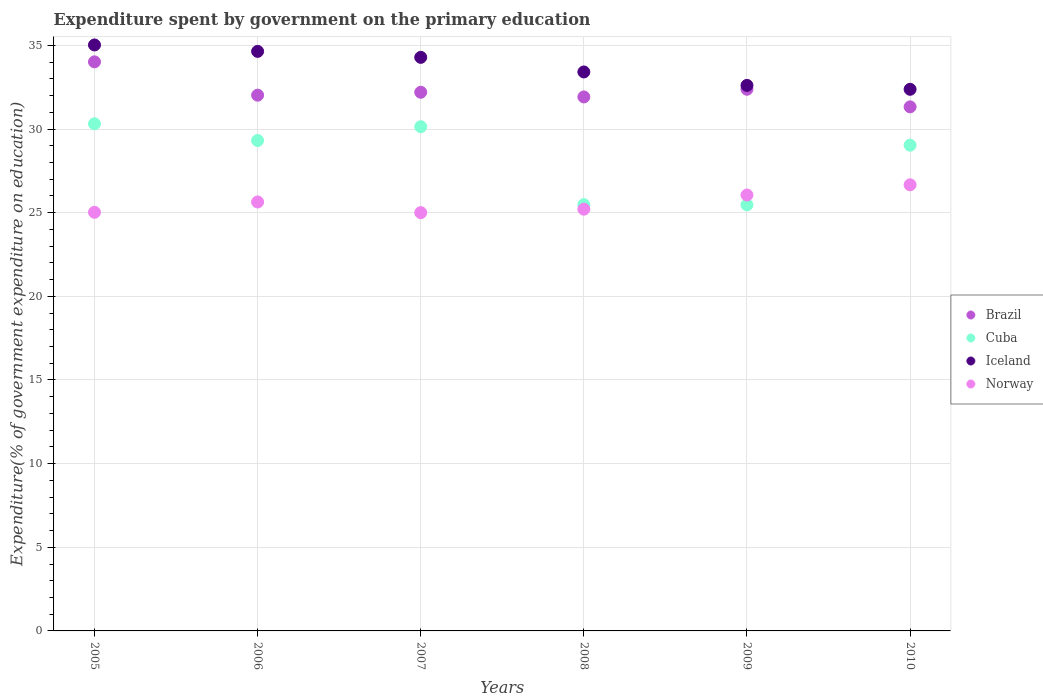What is the expenditure spent by government on the primary education in Norway in 2009?
Make the answer very short. 26.06. Across all years, what is the maximum expenditure spent by government on the primary education in Cuba?
Give a very brief answer. 30.31. Across all years, what is the minimum expenditure spent by government on the primary education in Brazil?
Make the answer very short. 31.33. In which year was the expenditure spent by government on the primary education in Brazil maximum?
Provide a succinct answer. 2005. In which year was the expenditure spent by government on the primary education in Norway minimum?
Provide a short and direct response. 2007. What is the total expenditure spent by government on the primary education in Norway in the graph?
Make the answer very short. 153.6. What is the difference between the expenditure spent by government on the primary education in Iceland in 2006 and that in 2008?
Offer a terse response. 1.23. What is the difference between the expenditure spent by government on the primary education in Brazil in 2005 and the expenditure spent by government on the primary education in Norway in 2010?
Your answer should be very brief. 7.35. What is the average expenditure spent by government on the primary education in Norway per year?
Your response must be concise. 25.6. In the year 2007, what is the difference between the expenditure spent by government on the primary education in Iceland and expenditure spent by government on the primary education in Norway?
Offer a terse response. 9.28. In how many years, is the expenditure spent by government on the primary education in Brazil greater than 32 %?
Provide a short and direct response. 4. What is the ratio of the expenditure spent by government on the primary education in Norway in 2005 to that in 2010?
Provide a succinct answer. 0.94. What is the difference between the highest and the second highest expenditure spent by government on the primary education in Norway?
Your answer should be compact. 0.61. What is the difference between the highest and the lowest expenditure spent by government on the primary education in Iceland?
Ensure brevity in your answer.  2.65. Is the sum of the expenditure spent by government on the primary education in Iceland in 2008 and 2009 greater than the maximum expenditure spent by government on the primary education in Cuba across all years?
Give a very brief answer. Yes. Is it the case that in every year, the sum of the expenditure spent by government on the primary education in Norway and expenditure spent by government on the primary education in Brazil  is greater than the sum of expenditure spent by government on the primary education in Iceland and expenditure spent by government on the primary education in Cuba?
Your answer should be very brief. Yes. Is it the case that in every year, the sum of the expenditure spent by government on the primary education in Cuba and expenditure spent by government on the primary education in Iceland  is greater than the expenditure spent by government on the primary education in Brazil?
Offer a terse response. Yes. What is the difference between two consecutive major ticks on the Y-axis?
Make the answer very short. 5. Are the values on the major ticks of Y-axis written in scientific E-notation?
Ensure brevity in your answer.  No. Does the graph contain any zero values?
Ensure brevity in your answer.  No. Does the graph contain grids?
Make the answer very short. Yes. Where does the legend appear in the graph?
Provide a succinct answer. Center right. How many legend labels are there?
Make the answer very short. 4. How are the legend labels stacked?
Give a very brief answer. Vertical. What is the title of the graph?
Ensure brevity in your answer.  Expenditure spent by government on the primary education. What is the label or title of the Y-axis?
Make the answer very short. Expenditure(% of government expenditure on education). What is the Expenditure(% of government expenditure on education) in Brazil in 2005?
Keep it short and to the point. 34.02. What is the Expenditure(% of government expenditure on education) in Cuba in 2005?
Give a very brief answer. 30.31. What is the Expenditure(% of government expenditure on education) of Iceland in 2005?
Provide a short and direct response. 35.03. What is the Expenditure(% of government expenditure on education) in Norway in 2005?
Your answer should be compact. 25.02. What is the Expenditure(% of government expenditure on education) of Brazil in 2006?
Provide a short and direct response. 32.02. What is the Expenditure(% of government expenditure on education) in Cuba in 2006?
Offer a terse response. 29.31. What is the Expenditure(% of government expenditure on education) in Iceland in 2006?
Provide a succinct answer. 34.64. What is the Expenditure(% of government expenditure on education) in Norway in 2006?
Offer a terse response. 25.64. What is the Expenditure(% of government expenditure on education) in Brazil in 2007?
Provide a short and direct response. 32.2. What is the Expenditure(% of government expenditure on education) of Cuba in 2007?
Offer a very short reply. 30.14. What is the Expenditure(% of government expenditure on education) in Iceland in 2007?
Give a very brief answer. 34.29. What is the Expenditure(% of government expenditure on education) in Norway in 2007?
Ensure brevity in your answer.  25. What is the Expenditure(% of government expenditure on education) in Brazil in 2008?
Your response must be concise. 31.92. What is the Expenditure(% of government expenditure on education) in Cuba in 2008?
Make the answer very short. 25.48. What is the Expenditure(% of government expenditure on education) in Iceland in 2008?
Keep it short and to the point. 33.41. What is the Expenditure(% of government expenditure on education) of Norway in 2008?
Your answer should be very brief. 25.21. What is the Expenditure(% of government expenditure on education) of Brazil in 2009?
Ensure brevity in your answer.  32.38. What is the Expenditure(% of government expenditure on education) in Cuba in 2009?
Provide a succinct answer. 25.47. What is the Expenditure(% of government expenditure on education) of Iceland in 2009?
Ensure brevity in your answer.  32.61. What is the Expenditure(% of government expenditure on education) in Norway in 2009?
Give a very brief answer. 26.06. What is the Expenditure(% of government expenditure on education) in Brazil in 2010?
Provide a succinct answer. 31.33. What is the Expenditure(% of government expenditure on education) of Cuba in 2010?
Ensure brevity in your answer.  29.04. What is the Expenditure(% of government expenditure on education) in Iceland in 2010?
Offer a terse response. 32.38. What is the Expenditure(% of government expenditure on education) in Norway in 2010?
Offer a terse response. 26.67. Across all years, what is the maximum Expenditure(% of government expenditure on education) of Brazil?
Provide a succinct answer. 34.02. Across all years, what is the maximum Expenditure(% of government expenditure on education) in Cuba?
Make the answer very short. 30.31. Across all years, what is the maximum Expenditure(% of government expenditure on education) in Iceland?
Offer a very short reply. 35.03. Across all years, what is the maximum Expenditure(% of government expenditure on education) in Norway?
Make the answer very short. 26.67. Across all years, what is the minimum Expenditure(% of government expenditure on education) in Brazil?
Ensure brevity in your answer.  31.33. Across all years, what is the minimum Expenditure(% of government expenditure on education) in Cuba?
Your answer should be very brief. 25.47. Across all years, what is the minimum Expenditure(% of government expenditure on education) of Iceland?
Offer a very short reply. 32.38. Across all years, what is the minimum Expenditure(% of government expenditure on education) in Norway?
Your response must be concise. 25. What is the total Expenditure(% of government expenditure on education) in Brazil in the graph?
Give a very brief answer. 193.86. What is the total Expenditure(% of government expenditure on education) in Cuba in the graph?
Your response must be concise. 169.75. What is the total Expenditure(% of government expenditure on education) of Iceland in the graph?
Your response must be concise. 202.35. What is the total Expenditure(% of government expenditure on education) of Norway in the graph?
Offer a very short reply. 153.6. What is the difference between the Expenditure(% of government expenditure on education) in Brazil in 2005 and that in 2006?
Your answer should be very brief. 1.99. What is the difference between the Expenditure(% of government expenditure on education) in Cuba in 2005 and that in 2006?
Keep it short and to the point. 1. What is the difference between the Expenditure(% of government expenditure on education) in Iceland in 2005 and that in 2006?
Your answer should be compact. 0.38. What is the difference between the Expenditure(% of government expenditure on education) of Norway in 2005 and that in 2006?
Ensure brevity in your answer.  -0.62. What is the difference between the Expenditure(% of government expenditure on education) in Brazil in 2005 and that in 2007?
Your answer should be very brief. 1.82. What is the difference between the Expenditure(% of government expenditure on education) of Cuba in 2005 and that in 2007?
Offer a very short reply. 0.17. What is the difference between the Expenditure(% of government expenditure on education) in Iceland in 2005 and that in 2007?
Give a very brief answer. 0.74. What is the difference between the Expenditure(% of government expenditure on education) in Norway in 2005 and that in 2007?
Offer a very short reply. 0.02. What is the difference between the Expenditure(% of government expenditure on education) in Brazil in 2005 and that in 2008?
Give a very brief answer. 2.1. What is the difference between the Expenditure(% of government expenditure on education) in Cuba in 2005 and that in 2008?
Your answer should be compact. 4.83. What is the difference between the Expenditure(% of government expenditure on education) in Iceland in 2005 and that in 2008?
Give a very brief answer. 1.61. What is the difference between the Expenditure(% of government expenditure on education) in Norway in 2005 and that in 2008?
Provide a short and direct response. -0.19. What is the difference between the Expenditure(% of government expenditure on education) in Brazil in 2005 and that in 2009?
Your response must be concise. 1.64. What is the difference between the Expenditure(% of government expenditure on education) in Cuba in 2005 and that in 2009?
Keep it short and to the point. 4.85. What is the difference between the Expenditure(% of government expenditure on education) in Iceland in 2005 and that in 2009?
Give a very brief answer. 2.42. What is the difference between the Expenditure(% of government expenditure on education) of Norway in 2005 and that in 2009?
Keep it short and to the point. -1.03. What is the difference between the Expenditure(% of government expenditure on education) of Brazil in 2005 and that in 2010?
Your answer should be compact. 2.69. What is the difference between the Expenditure(% of government expenditure on education) of Cuba in 2005 and that in 2010?
Keep it short and to the point. 1.28. What is the difference between the Expenditure(% of government expenditure on education) in Iceland in 2005 and that in 2010?
Offer a very short reply. 2.65. What is the difference between the Expenditure(% of government expenditure on education) in Norway in 2005 and that in 2010?
Your answer should be very brief. -1.64. What is the difference between the Expenditure(% of government expenditure on education) in Brazil in 2006 and that in 2007?
Ensure brevity in your answer.  -0.17. What is the difference between the Expenditure(% of government expenditure on education) in Cuba in 2006 and that in 2007?
Your response must be concise. -0.82. What is the difference between the Expenditure(% of government expenditure on education) in Iceland in 2006 and that in 2007?
Ensure brevity in your answer.  0.36. What is the difference between the Expenditure(% of government expenditure on education) in Norway in 2006 and that in 2007?
Your answer should be compact. 0.64. What is the difference between the Expenditure(% of government expenditure on education) in Brazil in 2006 and that in 2008?
Provide a short and direct response. 0.11. What is the difference between the Expenditure(% of government expenditure on education) in Cuba in 2006 and that in 2008?
Your answer should be compact. 3.84. What is the difference between the Expenditure(% of government expenditure on education) in Iceland in 2006 and that in 2008?
Provide a succinct answer. 1.23. What is the difference between the Expenditure(% of government expenditure on education) of Norway in 2006 and that in 2008?
Your answer should be very brief. 0.43. What is the difference between the Expenditure(% of government expenditure on education) of Brazil in 2006 and that in 2009?
Give a very brief answer. -0.35. What is the difference between the Expenditure(% of government expenditure on education) in Cuba in 2006 and that in 2009?
Keep it short and to the point. 3.85. What is the difference between the Expenditure(% of government expenditure on education) of Iceland in 2006 and that in 2009?
Provide a short and direct response. 2.03. What is the difference between the Expenditure(% of government expenditure on education) of Norway in 2006 and that in 2009?
Your answer should be compact. -0.42. What is the difference between the Expenditure(% of government expenditure on education) of Brazil in 2006 and that in 2010?
Provide a short and direct response. 0.7. What is the difference between the Expenditure(% of government expenditure on education) of Cuba in 2006 and that in 2010?
Your answer should be compact. 0.28. What is the difference between the Expenditure(% of government expenditure on education) of Iceland in 2006 and that in 2010?
Offer a terse response. 2.27. What is the difference between the Expenditure(% of government expenditure on education) in Norway in 2006 and that in 2010?
Provide a succinct answer. -1.03. What is the difference between the Expenditure(% of government expenditure on education) in Brazil in 2007 and that in 2008?
Offer a very short reply. 0.28. What is the difference between the Expenditure(% of government expenditure on education) in Cuba in 2007 and that in 2008?
Your response must be concise. 4.66. What is the difference between the Expenditure(% of government expenditure on education) in Iceland in 2007 and that in 2008?
Provide a succinct answer. 0.87. What is the difference between the Expenditure(% of government expenditure on education) in Norway in 2007 and that in 2008?
Make the answer very short. -0.21. What is the difference between the Expenditure(% of government expenditure on education) of Brazil in 2007 and that in 2009?
Your answer should be very brief. -0.18. What is the difference between the Expenditure(% of government expenditure on education) of Cuba in 2007 and that in 2009?
Offer a very short reply. 4.67. What is the difference between the Expenditure(% of government expenditure on education) of Iceland in 2007 and that in 2009?
Offer a terse response. 1.68. What is the difference between the Expenditure(% of government expenditure on education) of Norway in 2007 and that in 2009?
Your answer should be compact. -1.05. What is the difference between the Expenditure(% of government expenditure on education) in Brazil in 2007 and that in 2010?
Provide a succinct answer. 0.87. What is the difference between the Expenditure(% of government expenditure on education) of Cuba in 2007 and that in 2010?
Give a very brief answer. 1.1. What is the difference between the Expenditure(% of government expenditure on education) of Iceland in 2007 and that in 2010?
Make the answer very short. 1.91. What is the difference between the Expenditure(% of government expenditure on education) of Norway in 2007 and that in 2010?
Your answer should be very brief. -1.66. What is the difference between the Expenditure(% of government expenditure on education) in Brazil in 2008 and that in 2009?
Make the answer very short. -0.46. What is the difference between the Expenditure(% of government expenditure on education) in Cuba in 2008 and that in 2009?
Give a very brief answer. 0.01. What is the difference between the Expenditure(% of government expenditure on education) in Iceland in 2008 and that in 2009?
Make the answer very short. 0.8. What is the difference between the Expenditure(% of government expenditure on education) of Norway in 2008 and that in 2009?
Ensure brevity in your answer.  -0.85. What is the difference between the Expenditure(% of government expenditure on education) in Brazil in 2008 and that in 2010?
Offer a very short reply. 0.59. What is the difference between the Expenditure(% of government expenditure on education) in Cuba in 2008 and that in 2010?
Offer a very short reply. -3.56. What is the difference between the Expenditure(% of government expenditure on education) in Iceland in 2008 and that in 2010?
Make the answer very short. 1.04. What is the difference between the Expenditure(% of government expenditure on education) of Norway in 2008 and that in 2010?
Give a very brief answer. -1.46. What is the difference between the Expenditure(% of government expenditure on education) in Brazil in 2009 and that in 2010?
Provide a succinct answer. 1.05. What is the difference between the Expenditure(% of government expenditure on education) in Cuba in 2009 and that in 2010?
Ensure brevity in your answer.  -3.57. What is the difference between the Expenditure(% of government expenditure on education) of Iceland in 2009 and that in 2010?
Your response must be concise. 0.23. What is the difference between the Expenditure(% of government expenditure on education) in Norway in 2009 and that in 2010?
Your answer should be compact. -0.61. What is the difference between the Expenditure(% of government expenditure on education) in Brazil in 2005 and the Expenditure(% of government expenditure on education) in Cuba in 2006?
Make the answer very short. 4.7. What is the difference between the Expenditure(% of government expenditure on education) in Brazil in 2005 and the Expenditure(% of government expenditure on education) in Iceland in 2006?
Your response must be concise. -0.63. What is the difference between the Expenditure(% of government expenditure on education) in Brazil in 2005 and the Expenditure(% of government expenditure on education) in Norway in 2006?
Make the answer very short. 8.38. What is the difference between the Expenditure(% of government expenditure on education) of Cuba in 2005 and the Expenditure(% of government expenditure on education) of Iceland in 2006?
Offer a very short reply. -4.33. What is the difference between the Expenditure(% of government expenditure on education) in Cuba in 2005 and the Expenditure(% of government expenditure on education) in Norway in 2006?
Ensure brevity in your answer.  4.67. What is the difference between the Expenditure(% of government expenditure on education) of Iceland in 2005 and the Expenditure(% of government expenditure on education) of Norway in 2006?
Provide a short and direct response. 9.39. What is the difference between the Expenditure(% of government expenditure on education) in Brazil in 2005 and the Expenditure(% of government expenditure on education) in Cuba in 2007?
Provide a short and direct response. 3.88. What is the difference between the Expenditure(% of government expenditure on education) in Brazil in 2005 and the Expenditure(% of government expenditure on education) in Iceland in 2007?
Provide a succinct answer. -0.27. What is the difference between the Expenditure(% of government expenditure on education) in Brazil in 2005 and the Expenditure(% of government expenditure on education) in Norway in 2007?
Keep it short and to the point. 9.01. What is the difference between the Expenditure(% of government expenditure on education) of Cuba in 2005 and the Expenditure(% of government expenditure on education) of Iceland in 2007?
Offer a terse response. -3.97. What is the difference between the Expenditure(% of government expenditure on education) in Cuba in 2005 and the Expenditure(% of government expenditure on education) in Norway in 2007?
Offer a terse response. 5.31. What is the difference between the Expenditure(% of government expenditure on education) in Iceland in 2005 and the Expenditure(% of government expenditure on education) in Norway in 2007?
Provide a short and direct response. 10.02. What is the difference between the Expenditure(% of government expenditure on education) of Brazil in 2005 and the Expenditure(% of government expenditure on education) of Cuba in 2008?
Your answer should be compact. 8.54. What is the difference between the Expenditure(% of government expenditure on education) in Brazil in 2005 and the Expenditure(% of government expenditure on education) in Iceland in 2008?
Your answer should be compact. 0.6. What is the difference between the Expenditure(% of government expenditure on education) of Brazil in 2005 and the Expenditure(% of government expenditure on education) of Norway in 2008?
Offer a terse response. 8.8. What is the difference between the Expenditure(% of government expenditure on education) in Cuba in 2005 and the Expenditure(% of government expenditure on education) in Iceland in 2008?
Provide a succinct answer. -3.1. What is the difference between the Expenditure(% of government expenditure on education) in Cuba in 2005 and the Expenditure(% of government expenditure on education) in Norway in 2008?
Ensure brevity in your answer.  5.1. What is the difference between the Expenditure(% of government expenditure on education) of Iceland in 2005 and the Expenditure(% of government expenditure on education) of Norway in 2008?
Make the answer very short. 9.82. What is the difference between the Expenditure(% of government expenditure on education) in Brazil in 2005 and the Expenditure(% of government expenditure on education) in Cuba in 2009?
Your answer should be compact. 8.55. What is the difference between the Expenditure(% of government expenditure on education) in Brazil in 2005 and the Expenditure(% of government expenditure on education) in Iceland in 2009?
Make the answer very short. 1.41. What is the difference between the Expenditure(% of government expenditure on education) of Brazil in 2005 and the Expenditure(% of government expenditure on education) of Norway in 2009?
Keep it short and to the point. 7.96. What is the difference between the Expenditure(% of government expenditure on education) in Cuba in 2005 and the Expenditure(% of government expenditure on education) in Iceland in 2009?
Offer a terse response. -2.3. What is the difference between the Expenditure(% of government expenditure on education) of Cuba in 2005 and the Expenditure(% of government expenditure on education) of Norway in 2009?
Offer a very short reply. 4.26. What is the difference between the Expenditure(% of government expenditure on education) of Iceland in 2005 and the Expenditure(% of government expenditure on education) of Norway in 2009?
Offer a terse response. 8.97. What is the difference between the Expenditure(% of government expenditure on education) of Brazil in 2005 and the Expenditure(% of government expenditure on education) of Cuba in 2010?
Your answer should be very brief. 4.98. What is the difference between the Expenditure(% of government expenditure on education) of Brazil in 2005 and the Expenditure(% of government expenditure on education) of Iceland in 2010?
Give a very brief answer. 1.64. What is the difference between the Expenditure(% of government expenditure on education) in Brazil in 2005 and the Expenditure(% of government expenditure on education) in Norway in 2010?
Offer a terse response. 7.35. What is the difference between the Expenditure(% of government expenditure on education) of Cuba in 2005 and the Expenditure(% of government expenditure on education) of Iceland in 2010?
Make the answer very short. -2.06. What is the difference between the Expenditure(% of government expenditure on education) of Cuba in 2005 and the Expenditure(% of government expenditure on education) of Norway in 2010?
Your answer should be very brief. 3.65. What is the difference between the Expenditure(% of government expenditure on education) in Iceland in 2005 and the Expenditure(% of government expenditure on education) in Norway in 2010?
Your response must be concise. 8.36. What is the difference between the Expenditure(% of government expenditure on education) in Brazil in 2006 and the Expenditure(% of government expenditure on education) in Cuba in 2007?
Make the answer very short. 1.89. What is the difference between the Expenditure(% of government expenditure on education) of Brazil in 2006 and the Expenditure(% of government expenditure on education) of Iceland in 2007?
Keep it short and to the point. -2.26. What is the difference between the Expenditure(% of government expenditure on education) of Brazil in 2006 and the Expenditure(% of government expenditure on education) of Norway in 2007?
Keep it short and to the point. 7.02. What is the difference between the Expenditure(% of government expenditure on education) in Cuba in 2006 and the Expenditure(% of government expenditure on education) in Iceland in 2007?
Offer a terse response. -4.97. What is the difference between the Expenditure(% of government expenditure on education) of Cuba in 2006 and the Expenditure(% of government expenditure on education) of Norway in 2007?
Your response must be concise. 4.31. What is the difference between the Expenditure(% of government expenditure on education) of Iceland in 2006 and the Expenditure(% of government expenditure on education) of Norway in 2007?
Your answer should be very brief. 9.64. What is the difference between the Expenditure(% of government expenditure on education) of Brazil in 2006 and the Expenditure(% of government expenditure on education) of Cuba in 2008?
Your answer should be compact. 6.55. What is the difference between the Expenditure(% of government expenditure on education) of Brazil in 2006 and the Expenditure(% of government expenditure on education) of Iceland in 2008?
Provide a succinct answer. -1.39. What is the difference between the Expenditure(% of government expenditure on education) in Brazil in 2006 and the Expenditure(% of government expenditure on education) in Norway in 2008?
Provide a succinct answer. 6.81. What is the difference between the Expenditure(% of government expenditure on education) in Cuba in 2006 and the Expenditure(% of government expenditure on education) in Iceland in 2008?
Provide a succinct answer. -4.1. What is the difference between the Expenditure(% of government expenditure on education) in Cuba in 2006 and the Expenditure(% of government expenditure on education) in Norway in 2008?
Offer a very short reply. 4.1. What is the difference between the Expenditure(% of government expenditure on education) of Iceland in 2006 and the Expenditure(% of government expenditure on education) of Norway in 2008?
Provide a short and direct response. 9.43. What is the difference between the Expenditure(% of government expenditure on education) in Brazil in 2006 and the Expenditure(% of government expenditure on education) in Cuba in 2009?
Provide a succinct answer. 6.56. What is the difference between the Expenditure(% of government expenditure on education) of Brazil in 2006 and the Expenditure(% of government expenditure on education) of Iceland in 2009?
Your answer should be compact. -0.58. What is the difference between the Expenditure(% of government expenditure on education) in Brazil in 2006 and the Expenditure(% of government expenditure on education) in Norway in 2009?
Provide a short and direct response. 5.97. What is the difference between the Expenditure(% of government expenditure on education) of Cuba in 2006 and the Expenditure(% of government expenditure on education) of Iceland in 2009?
Your response must be concise. -3.29. What is the difference between the Expenditure(% of government expenditure on education) in Cuba in 2006 and the Expenditure(% of government expenditure on education) in Norway in 2009?
Give a very brief answer. 3.26. What is the difference between the Expenditure(% of government expenditure on education) in Iceland in 2006 and the Expenditure(% of government expenditure on education) in Norway in 2009?
Your answer should be compact. 8.59. What is the difference between the Expenditure(% of government expenditure on education) in Brazil in 2006 and the Expenditure(% of government expenditure on education) in Cuba in 2010?
Your answer should be compact. 2.99. What is the difference between the Expenditure(% of government expenditure on education) of Brazil in 2006 and the Expenditure(% of government expenditure on education) of Iceland in 2010?
Keep it short and to the point. -0.35. What is the difference between the Expenditure(% of government expenditure on education) in Brazil in 2006 and the Expenditure(% of government expenditure on education) in Norway in 2010?
Offer a terse response. 5.36. What is the difference between the Expenditure(% of government expenditure on education) of Cuba in 2006 and the Expenditure(% of government expenditure on education) of Iceland in 2010?
Your answer should be compact. -3.06. What is the difference between the Expenditure(% of government expenditure on education) in Cuba in 2006 and the Expenditure(% of government expenditure on education) in Norway in 2010?
Offer a terse response. 2.65. What is the difference between the Expenditure(% of government expenditure on education) of Iceland in 2006 and the Expenditure(% of government expenditure on education) of Norway in 2010?
Your response must be concise. 7.98. What is the difference between the Expenditure(% of government expenditure on education) in Brazil in 2007 and the Expenditure(% of government expenditure on education) in Cuba in 2008?
Your answer should be compact. 6.72. What is the difference between the Expenditure(% of government expenditure on education) of Brazil in 2007 and the Expenditure(% of government expenditure on education) of Iceland in 2008?
Your response must be concise. -1.21. What is the difference between the Expenditure(% of government expenditure on education) of Brazil in 2007 and the Expenditure(% of government expenditure on education) of Norway in 2008?
Keep it short and to the point. 6.99. What is the difference between the Expenditure(% of government expenditure on education) in Cuba in 2007 and the Expenditure(% of government expenditure on education) in Iceland in 2008?
Offer a terse response. -3.27. What is the difference between the Expenditure(% of government expenditure on education) in Cuba in 2007 and the Expenditure(% of government expenditure on education) in Norway in 2008?
Make the answer very short. 4.93. What is the difference between the Expenditure(% of government expenditure on education) of Iceland in 2007 and the Expenditure(% of government expenditure on education) of Norway in 2008?
Offer a very short reply. 9.07. What is the difference between the Expenditure(% of government expenditure on education) in Brazil in 2007 and the Expenditure(% of government expenditure on education) in Cuba in 2009?
Offer a terse response. 6.73. What is the difference between the Expenditure(% of government expenditure on education) in Brazil in 2007 and the Expenditure(% of government expenditure on education) in Iceland in 2009?
Give a very brief answer. -0.41. What is the difference between the Expenditure(% of government expenditure on education) of Brazil in 2007 and the Expenditure(% of government expenditure on education) of Norway in 2009?
Provide a succinct answer. 6.14. What is the difference between the Expenditure(% of government expenditure on education) in Cuba in 2007 and the Expenditure(% of government expenditure on education) in Iceland in 2009?
Your answer should be very brief. -2.47. What is the difference between the Expenditure(% of government expenditure on education) in Cuba in 2007 and the Expenditure(% of government expenditure on education) in Norway in 2009?
Give a very brief answer. 4.08. What is the difference between the Expenditure(% of government expenditure on education) in Iceland in 2007 and the Expenditure(% of government expenditure on education) in Norway in 2009?
Offer a terse response. 8.23. What is the difference between the Expenditure(% of government expenditure on education) of Brazil in 2007 and the Expenditure(% of government expenditure on education) of Cuba in 2010?
Provide a succinct answer. 3.16. What is the difference between the Expenditure(% of government expenditure on education) in Brazil in 2007 and the Expenditure(% of government expenditure on education) in Iceland in 2010?
Your response must be concise. -0.18. What is the difference between the Expenditure(% of government expenditure on education) in Brazil in 2007 and the Expenditure(% of government expenditure on education) in Norway in 2010?
Provide a short and direct response. 5.53. What is the difference between the Expenditure(% of government expenditure on education) in Cuba in 2007 and the Expenditure(% of government expenditure on education) in Iceland in 2010?
Provide a succinct answer. -2.24. What is the difference between the Expenditure(% of government expenditure on education) of Cuba in 2007 and the Expenditure(% of government expenditure on education) of Norway in 2010?
Keep it short and to the point. 3.47. What is the difference between the Expenditure(% of government expenditure on education) in Iceland in 2007 and the Expenditure(% of government expenditure on education) in Norway in 2010?
Your answer should be compact. 7.62. What is the difference between the Expenditure(% of government expenditure on education) in Brazil in 2008 and the Expenditure(% of government expenditure on education) in Cuba in 2009?
Your answer should be compact. 6.45. What is the difference between the Expenditure(% of government expenditure on education) of Brazil in 2008 and the Expenditure(% of government expenditure on education) of Iceland in 2009?
Your answer should be very brief. -0.69. What is the difference between the Expenditure(% of government expenditure on education) of Brazil in 2008 and the Expenditure(% of government expenditure on education) of Norway in 2009?
Your response must be concise. 5.86. What is the difference between the Expenditure(% of government expenditure on education) of Cuba in 2008 and the Expenditure(% of government expenditure on education) of Iceland in 2009?
Your answer should be compact. -7.13. What is the difference between the Expenditure(% of government expenditure on education) of Cuba in 2008 and the Expenditure(% of government expenditure on education) of Norway in 2009?
Keep it short and to the point. -0.58. What is the difference between the Expenditure(% of government expenditure on education) in Iceland in 2008 and the Expenditure(% of government expenditure on education) in Norway in 2009?
Ensure brevity in your answer.  7.36. What is the difference between the Expenditure(% of government expenditure on education) of Brazil in 2008 and the Expenditure(% of government expenditure on education) of Cuba in 2010?
Keep it short and to the point. 2.88. What is the difference between the Expenditure(% of government expenditure on education) of Brazil in 2008 and the Expenditure(% of government expenditure on education) of Iceland in 2010?
Keep it short and to the point. -0.46. What is the difference between the Expenditure(% of government expenditure on education) in Brazil in 2008 and the Expenditure(% of government expenditure on education) in Norway in 2010?
Give a very brief answer. 5.25. What is the difference between the Expenditure(% of government expenditure on education) in Cuba in 2008 and the Expenditure(% of government expenditure on education) in Iceland in 2010?
Your answer should be compact. -6.9. What is the difference between the Expenditure(% of government expenditure on education) of Cuba in 2008 and the Expenditure(% of government expenditure on education) of Norway in 2010?
Your answer should be very brief. -1.19. What is the difference between the Expenditure(% of government expenditure on education) in Iceland in 2008 and the Expenditure(% of government expenditure on education) in Norway in 2010?
Offer a very short reply. 6.75. What is the difference between the Expenditure(% of government expenditure on education) of Brazil in 2009 and the Expenditure(% of government expenditure on education) of Cuba in 2010?
Keep it short and to the point. 3.34. What is the difference between the Expenditure(% of government expenditure on education) of Brazil in 2009 and the Expenditure(% of government expenditure on education) of Iceland in 2010?
Your answer should be compact. 0. What is the difference between the Expenditure(% of government expenditure on education) in Brazil in 2009 and the Expenditure(% of government expenditure on education) in Norway in 2010?
Provide a succinct answer. 5.71. What is the difference between the Expenditure(% of government expenditure on education) of Cuba in 2009 and the Expenditure(% of government expenditure on education) of Iceland in 2010?
Make the answer very short. -6.91. What is the difference between the Expenditure(% of government expenditure on education) in Cuba in 2009 and the Expenditure(% of government expenditure on education) in Norway in 2010?
Offer a terse response. -1.2. What is the difference between the Expenditure(% of government expenditure on education) in Iceland in 2009 and the Expenditure(% of government expenditure on education) in Norway in 2010?
Your answer should be very brief. 5.94. What is the average Expenditure(% of government expenditure on education) in Brazil per year?
Keep it short and to the point. 32.31. What is the average Expenditure(% of government expenditure on education) in Cuba per year?
Provide a succinct answer. 28.29. What is the average Expenditure(% of government expenditure on education) of Iceland per year?
Make the answer very short. 33.72. What is the average Expenditure(% of government expenditure on education) in Norway per year?
Offer a very short reply. 25.6. In the year 2005, what is the difference between the Expenditure(% of government expenditure on education) in Brazil and Expenditure(% of government expenditure on education) in Cuba?
Ensure brevity in your answer.  3.7. In the year 2005, what is the difference between the Expenditure(% of government expenditure on education) of Brazil and Expenditure(% of government expenditure on education) of Iceland?
Your response must be concise. -1.01. In the year 2005, what is the difference between the Expenditure(% of government expenditure on education) of Brazil and Expenditure(% of government expenditure on education) of Norway?
Give a very brief answer. 8.99. In the year 2005, what is the difference between the Expenditure(% of government expenditure on education) in Cuba and Expenditure(% of government expenditure on education) in Iceland?
Make the answer very short. -4.71. In the year 2005, what is the difference between the Expenditure(% of government expenditure on education) of Cuba and Expenditure(% of government expenditure on education) of Norway?
Provide a succinct answer. 5.29. In the year 2005, what is the difference between the Expenditure(% of government expenditure on education) in Iceland and Expenditure(% of government expenditure on education) in Norway?
Your response must be concise. 10. In the year 2006, what is the difference between the Expenditure(% of government expenditure on education) in Brazil and Expenditure(% of government expenditure on education) in Cuba?
Your answer should be very brief. 2.71. In the year 2006, what is the difference between the Expenditure(% of government expenditure on education) of Brazil and Expenditure(% of government expenditure on education) of Iceland?
Make the answer very short. -2.62. In the year 2006, what is the difference between the Expenditure(% of government expenditure on education) in Brazil and Expenditure(% of government expenditure on education) in Norway?
Your response must be concise. 6.38. In the year 2006, what is the difference between the Expenditure(% of government expenditure on education) of Cuba and Expenditure(% of government expenditure on education) of Iceland?
Make the answer very short. -5.33. In the year 2006, what is the difference between the Expenditure(% of government expenditure on education) in Cuba and Expenditure(% of government expenditure on education) in Norway?
Offer a very short reply. 3.67. In the year 2006, what is the difference between the Expenditure(% of government expenditure on education) in Iceland and Expenditure(% of government expenditure on education) in Norway?
Your response must be concise. 9. In the year 2007, what is the difference between the Expenditure(% of government expenditure on education) of Brazil and Expenditure(% of government expenditure on education) of Cuba?
Give a very brief answer. 2.06. In the year 2007, what is the difference between the Expenditure(% of government expenditure on education) of Brazil and Expenditure(% of government expenditure on education) of Iceland?
Keep it short and to the point. -2.09. In the year 2007, what is the difference between the Expenditure(% of government expenditure on education) in Brazil and Expenditure(% of government expenditure on education) in Norway?
Provide a short and direct response. 7.2. In the year 2007, what is the difference between the Expenditure(% of government expenditure on education) in Cuba and Expenditure(% of government expenditure on education) in Iceland?
Give a very brief answer. -4.15. In the year 2007, what is the difference between the Expenditure(% of government expenditure on education) in Cuba and Expenditure(% of government expenditure on education) in Norway?
Make the answer very short. 5.14. In the year 2007, what is the difference between the Expenditure(% of government expenditure on education) in Iceland and Expenditure(% of government expenditure on education) in Norway?
Ensure brevity in your answer.  9.28. In the year 2008, what is the difference between the Expenditure(% of government expenditure on education) in Brazil and Expenditure(% of government expenditure on education) in Cuba?
Keep it short and to the point. 6.44. In the year 2008, what is the difference between the Expenditure(% of government expenditure on education) in Brazil and Expenditure(% of government expenditure on education) in Iceland?
Keep it short and to the point. -1.49. In the year 2008, what is the difference between the Expenditure(% of government expenditure on education) of Brazil and Expenditure(% of government expenditure on education) of Norway?
Provide a short and direct response. 6.71. In the year 2008, what is the difference between the Expenditure(% of government expenditure on education) of Cuba and Expenditure(% of government expenditure on education) of Iceland?
Your response must be concise. -7.93. In the year 2008, what is the difference between the Expenditure(% of government expenditure on education) of Cuba and Expenditure(% of government expenditure on education) of Norway?
Provide a succinct answer. 0.27. In the year 2008, what is the difference between the Expenditure(% of government expenditure on education) in Iceland and Expenditure(% of government expenditure on education) in Norway?
Your answer should be very brief. 8.2. In the year 2009, what is the difference between the Expenditure(% of government expenditure on education) in Brazil and Expenditure(% of government expenditure on education) in Cuba?
Provide a short and direct response. 6.91. In the year 2009, what is the difference between the Expenditure(% of government expenditure on education) in Brazil and Expenditure(% of government expenditure on education) in Iceland?
Give a very brief answer. -0.23. In the year 2009, what is the difference between the Expenditure(% of government expenditure on education) of Brazil and Expenditure(% of government expenditure on education) of Norway?
Provide a short and direct response. 6.32. In the year 2009, what is the difference between the Expenditure(% of government expenditure on education) of Cuba and Expenditure(% of government expenditure on education) of Iceland?
Provide a short and direct response. -7.14. In the year 2009, what is the difference between the Expenditure(% of government expenditure on education) of Cuba and Expenditure(% of government expenditure on education) of Norway?
Your response must be concise. -0.59. In the year 2009, what is the difference between the Expenditure(% of government expenditure on education) in Iceland and Expenditure(% of government expenditure on education) in Norway?
Give a very brief answer. 6.55. In the year 2010, what is the difference between the Expenditure(% of government expenditure on education) of Brazil and Expenditure(% of government expenditure on education) of Cuba?
Keep it short and to the point. 2.29. In the year 2010, what is the difference between the Expenditure(% of government expenditure on education) in Brazil and Expenditure(% of government expenditure on education) in Iceland?
Provide a succinct answer. -1.05. In the year 2010, what is the difference between the Expenditure(% of government expenditure on education) of Brazil and Expenditure(% of government expenditure on education) of Norway?
Give a very brief answer. 4.66. In the year 2010, what is the difference between the Expenditure(% of government expenditure on education) in Cuba and Expenditure(% of government expenditure on education) in Iceland?
Make the answer very short. -3.34. In the year 2010, what is the difference between the Expenditure(% of government expenditure on education) in Cuba and Expenditure(% of government expenditure on education) in Norway?
Keep it short and to the point. 2.37. In the year 2010, what is the difference between the Expenditure(% of government expenditure on education) in Iceland and Expenditure(% of government expenditure on education) in Norway?
Give a very brief answer. 5.71. What is the ratio of the Expenditure(% of government expenditure on education) of Brazil in 2005 to that in 2006?
Give a very brief answer. 1.06. What is the ratio of the Expenditure(% of government expenditure on education) of Cuba in 2005 to that in 2006?
Provide a succinct answer. 1.03. What is the ratio of the Expenditure(% of government expenditure on education) in Iceland in 2005 to that in 2006?
Provide a short and direct response. 1.01. What is the ratio of the Expenditure(% of government expenditure on education) in Norway in 2005 to that in 2006?
Provide a short and direct response. 0.98. What is the ratio of the Expenditure(% of government expenditure on education) in Brazil in 2005 to that in 2007?
Your response must be concise. 1.06. What is the ratio of the Expenditure(% of government expenditure on education) of Iceland in 2005 to that in 2007?
Give a very brief answer. 1.02. What is the ratio of the Expenditure(% of government expenditure on education) in Norway in 2005 to that in 2007?
Offer a very short reply. 1. What is the ratio of the Expenditure(% of government expenditure on education) in Brazil in 2005 to that in 2008?
Offer a terse response. 1.07. What is the ratio of the Expenditure(% of government expenditure on education) of Cuba in 2005 to that in 2008?
Ensure brevity in your answer.  1.19. What is the ratio of the Expenditure(% of government expenditure on education) in Iceland in 2005 to that in 2008?
Your answer should be very brief. 1.05. What is the ratio of the Expenditure(% of government expenditure on education) in Norway in 2005 to that in 2008?
Provide a short and direct response. 0.99. What is the ratio of the Expenditure(% of government expenditure on education) in Brazil in 2005 to that in 2009?
Ensure brevity in your answer.  1.05. What is the ratio of the Expenditure(% of government expenditure on education) of Cuba in 2005 to that in 2009?
Provide a succinct answer. 1.19. What is the ratio of the Expenditure(% of government expenditure on education) of Iceland in 2005 to that in 2009?
Offer a terse response. 1.07. What is the ratio of the Expenditure(% of government expenditure on education) of Norway in 2005 to that in 2009?
Offer a terse response. 0.96. What is the ratio of the Expenditure(% of government expenditure on education) of Brazil in 2005 to that in 2010?
Provide a succinct answer. 1.09. What is the ratio of the Expenditure(% of government expenditure on education) of Cuba in 2005 to that in 2010?
Your answer should be very brief. 1.04. What is the ratio of the Expenditure(% of government expenditure on education) in Iceland in 2005 to that in 2010?
Provide a succinct answer. 1.08. What is the ratio of the Expenditure(% of government expenditure on education) in Norway in 2005 to that in 2010?
Offer a very short reply. 0.94. What is the ratio of the Expenditure(% of government expenditure on education) of Brazil in 2006 to that in 2007?
Your response must be concise. 0.99. What is the ratio of the Expenditure(% of government expenditure on education) of Cuba in 2006 to that in 2007?
Offer a very short reply. 0.97. What is the ratio of the Expenditure(% of government expenditure on education) in Iceland in 2006 to that in 2007?
Give a very brief answer. 1.01. What is the ratio of the Expenditure(% of government expenditure on education) of Norway in 2006 to that in 2007?
Your answer should be very brief. 1.03. What is the ratio of the Expenditure(% of government expenditure on education) of Cuba in 2006 to that in 2008?
Provide a succinct answer. 1.15. What is the ratio of the Expenditure(% of government expenditure on education) in Iceland in 2006 to that in 2008?
Offer a terse response. 1.04. What is the ratio of the Expenditure(% of government expenditure on education) in Cuba in 2006 to that in 2009?
Your answer should be compact. 1.15. What is the ratio of the Expenditure(% of government expenditure on education) of Iceland in 2006 to that in 2009?
Your response must be concise. 1.06. What is the ratio of the Expenditure(% of government expenditure on education) of Brazil in 2006 to that in 2010?
Your answer should be very brief. 1.02. What is the ratio of the Expenditure(% of government expenditure on education) in Cuba in 2006 to that in 2010?
Offer a terse response. 1.01. What is the ratio of the Expenditure(% of government expenditure on education) of Iceland in 2006 to that in 2010?
Keep it short and to the point. 1.07. What is the ratio of the Expenditure(% of government expenditure on education) of Norway in 2006 to that in 2010?
Provide a short and direct response. 0.96. What is the ratio of the Expenditure(% of government expenditure on education) of Brazil in 2007 to that in 2008?
Give a very brief answer. 1.01. What is the ratio of the Expenditure(% of government expenditure on education) in Cuba in 2007 to that in 2008?
Provide a succinct answer. 1.18. What is the ratio of the Expenditure(% of government expenditure on education) in Iceland in 2007 to that in 2008?
Make the answer very short. 1.03. What is the ratio of the Expenditure(% of government expenditure on education) of Norway in 2007 to that in 2008?
Keep it short and to the point. 0.99. What is the ratio of the Expenditure(% of government expenditure on education) in Brazil in 2007 to that in 2009?
Your response must be concise. 0.99. What is the ratio of the Expenditure(% of government expenditure on education) in Cuba in 2007 to that in 2009?
Your response must be concise. 1.18. What is the ratio of the Expenditure(% of government expenditure on education) of Iceland in 2007 to that in 2009?
Give a very brief answer. 1.05. What is the ratio of the Expenditure(% of government expenditure on education) in Norway in 2007 to that in 2009?
Your answer should be compact. 0.96. What is the ratio of the Expenditure(% of government expenditure on education) of Brazil in 2007 to that in 2010?
Give a very brief answer. 1.03. What is the ratio of the Expenditure(% of government expenditure on education) in Cuba in 2007 to that in 2010?
Offer a terse response. 1.04. What is the ratio of the Expenditure(% of government expenditure on education) of Iceland in 2007 to that in 2010?
Ensure brevity in your answer.  1.06. What is the ratio of the Expenditure(% of government expenditure on education) in Norway in 2007 to that in 2010?
Ensure brevity in your answer.  0.94. What is the ratio of the Expenditure(% of government expenditure on education) in Brazil in 2008 to that in 2009?
Offer a terse response. 0.99. What is the ratio of the Expenditure(% of government expenditure on education) in Cuba in 2008 to that in 2009?
Your answer should be very brief. 1. What is the ratio of the Expenditure(% of government expenditure on education) of Iceland in 2008 to that in 2009?
Provide a succinct answer. 1.02. What is the ratio of the Expenditure(% of government expenditure on education) of Norway in 2008 to that in 2009?
Your response must be concise. 0.97. What is the ratio of the Expenditure(% of government expenditure on education) in Brazil in 2008 to that in 2010?
Your answer should be very brief. 1.02. What is the ratio of the Expenditure(% of government expenditure on education) of Cuba in 2008 to that in 2010?
Your answer should be very brief. 0.88. What is the ratio of the Expenditure(% of government expenditure on education) in Iceland in 2008 to that in 2010?
Your answer should be very brief. 1.03. What is the ratio of the Expenditure(% of government expenditure on education) in Norway in 2008 to that in 2010?
Provide a succinct answer. 0.95. What is the ratio of the Expenditure(% of government expenditure on education) in Brazil in 2009 to that in 2010?
Ensure brevity in your answer.  1.03. What is the ratio of the Expenditure(% of government expenditure on education) in Cuba in 2009 to that in 2010?
Your answer should be compact. 0.88. What is the ratio of the Expenditure(% of government expenditure on education) of Norway in 2009 to that in 2010?
Ensure brevity in your answer.  0.98. What is the difference between the highest and the second highest Expenditure(% of government expenditure on education) in Brazil?
Your answer should be very brief. 1.64. What is the difference between the highest and the second highest Expenditure(% of government expenditure on education) of Cuba?
Provide a succinct answer. 0.17. What is the difference between the highest and the second highest Expenditure(% of government expenditure on education) of Iceland?
Provide a short and direct response. 0.38. What is the difference between the highest and the second highest Expenditure(% of government expenditure on education) in Norway?
Provide a succinct answer. 0.61. What is the difference between the highest and the lowest Expenditure(% of government expenditure on education) in Brazil?
Ensure brevity in your answer.  2.69. What is the difference between the highest and the lowest Expenditure(% of government expenditure on education) of Cuba?
Keep it short and to the point. 4.85. What is the difference between the highest and the lowest Expenditure(% of government expenditure on education) of Iceland?
Your answer should be very brief. 2.65. What is the difference between the highest and the lowest Expenditure(% of government expenditure on education) in Norway?
Make the answer very short. 1.66. 